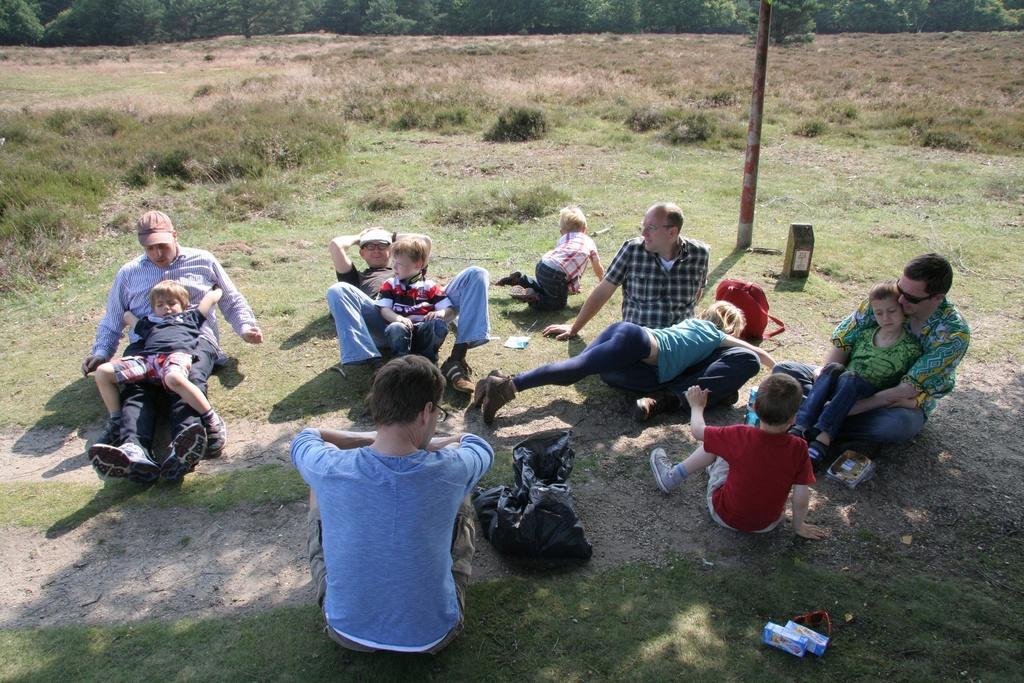In one or two sentences, can you explain what this image depicts? There are few people sitting and few people lying on the ground. This looks like a pole. I can see the grass and small bushes. In the background, I think these are the trees. These look like the bags. 